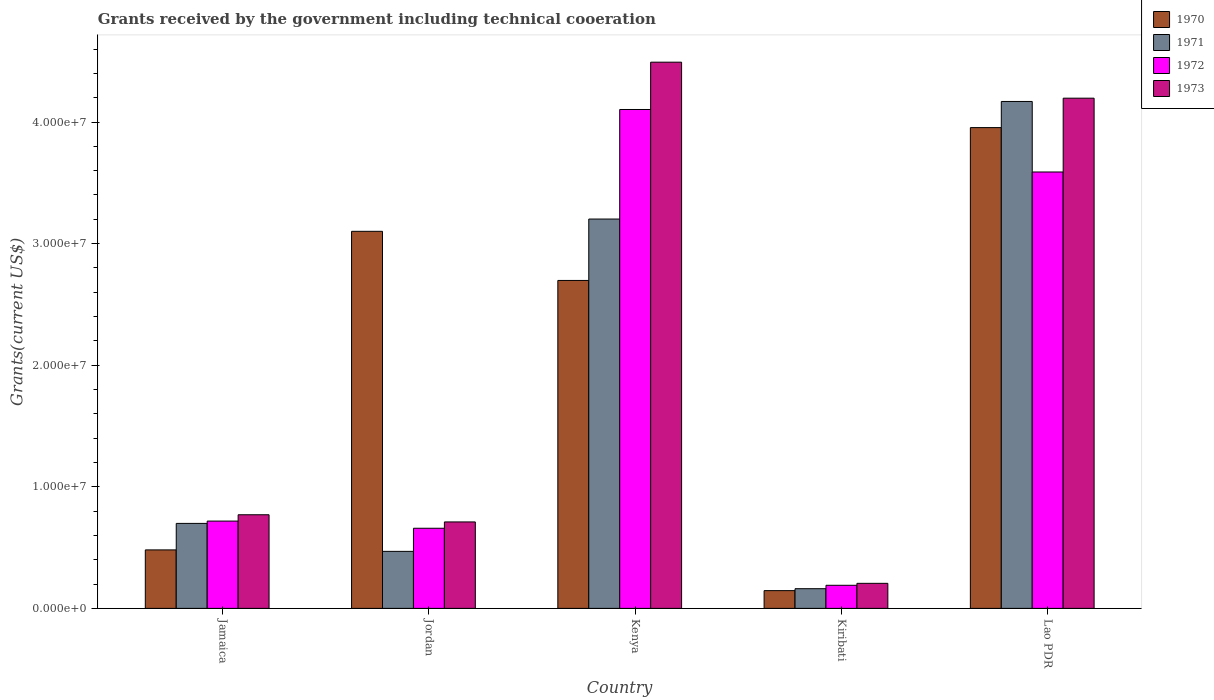How many different coloured bars are there?
Offer a terse response. 4. Are the number of bars per tick equal to the number of legend labels?
Make the answer very short. Yes. Are the number of bars on each tick of the X-axis equal?
Give a very brief answer. Yes. How many bars are there on the 5th tick from the right?
Provide a short and direct response. 4. What is the label of the 3rd group of bars from the left?
Provide a succinct answer. Kenya. What is the total grants received by the government in 1971 in Kiribati?
Your answer should be very brief. 1.62e+06. Across all countries, what is the maximum total grants received by the government in 1971?
Make the answer very short. 4.17e+07. Across all countries, what is the minimum total grants received by the government in 1970?
Provide a succinct answer. 1.46e+06. In which country was the total grants received by the government in 1973 maximum?
Give a very brief answer. Kenya. In which country was the total grants received by the government in 1971 minimum?
Ensure brevity in your answer.  Kiribati. What is the total total grants received by the government in 1970 in the graph?
Your answer should be very brief. 1.04e+08. What is the difference between the total grants received by the government in 1971 in Jamaica and that in Kiribati?
Provide a succinct answer. 5.37e+06. What is the difference between the total grants received by the government in 1971 in Kiribati and the total grants received by the government in 1973 in Kenya?
Make the answer very short. -4.33e+07. What is the average total grants received by the government in 1972 per country?
Make the answer very short. 1.85e+07. What is the difference between the total grants received by the government of/in 1973 and total grants received by the government of/in 1972 in Kenya?
Offer a terse response. 3.89e+06. In how many countries, is the total grants received by the government in 1970 greater than 8000000 US$?
Your answer should be compact. 3. What is the ratio of the total grants received by the government in 1970 in Jamaica to that in Kenya?
Your response must be concise. 0.18. Is the total grants received by the government in 1973 in Kenya less than that in Lao PDR?
Your response must be concise. No. Is the difference between the total grants received by the government in 1973 in Jamaica and Lao PDR greater than the difference between the total grants received by the government in 1972 in Jamaica and Lao PDR?
Offer a very short reply. No. What is the difference between the highest and the second highest total grants received by the government in 1973?
Provide a short and direct response. 3.72e+07. What is the difference between the highest and the lowest total grants received by the government in 1973?
Keep it short and to the point. 4.29e+07. In how many countries, is the total grants received by the government in 1971 greater than the average total grants received by the government in 1971 taken over all countries?
Provide a succinct answer. 2. Is the sum of the total grants received by the government in 1972 in Kenya and Lao PDR greater than the maximum total grants received by the government in 1971 across all countries?
Provide a short and direct response. Yes. Is it the case that in every country, the sum of the total grants received by the government in 1973 and total grants received by the government in 1971 is greater than the sum of total grants received by the government in 1970 and total grants received by the government in 1972?
Keep it short and to the point. No. How many bars are there?
Your response must be concise. 20. What is the difference between two consecutive major ticks on the Y-axis?
Offer a terse response. 1.00e+07. Does the graph contain any zero values?
Provide a short and direct response. No. Does the graph contain grids?
Provide a short and direct response. No. Where does the legend appear in the graph?
Offer a terse response. Top right. What is the title of the graph?
Make the answer very short. Grants received by the government including technical cooeration. What is the label or title of the Y-axis?
Keep it short and to the point. Grants(current US$). What is the Grants(current US$) in 1970 in Jamaica?
Your answer should be very brief. 4.81e+06. What is the Grants(current US$) in 1971 in Jamaica?
Provide a succinct answer. 6.99e+06. What is the Grants(current US$) in 1972 in Jamaica?
Your answer should be very brief. 7.18e+06. What is the Grants(current US$) in 1973 in Jamaica?
Make the answer very short. 7.70e+06. What is the Grants(current US$) in 1970 in Jordan?
Your response must be concise. 3.10e+07. What is the Grants(current US$) in 1971 in Jordan?
Offer a very short reply. 4.69e+06. What is the Grants(current US$) in 1972 in Jordan?
Provide a short and direct response. 6.59e+06. What is the Grants(current US$) of 1973 in Jordan?
Provide a short and direct response. 7.11e+06. What is the Grants(current US$) of 1970 in Kenya?
Your answer should be compact. 2.70e+07. What is the Grants(current US$) in 1971 in Kenya?
Your response must be concise. 3.20e+07. What is the Grants(current US$) in 1972 in Kenya?
Make the answer very short. 4.10e+07. What is the Grants(current US$) in 1973 in Kenya?
Offer a very short reply. 4.49e+07. What is the Grants(current US$) in 1970 in Kiribati?
Ensure brevity in your answer.  1.46e+06. What is the Grants(current US$) of 1971 in Kiribati?
Your response must be concise. 1.62e+06. What is the Grants(current US$) in 1972 in Kiribati?
Your answer should be compact. 1.90e+06. What is the Grants(current US$) of 1973 in Kiribati?
Provide a short and direct response. 2.06e+06. What is the Grants(current US$) of 1970 in Lao PDR?
Your response must be concise. 3.95e+07. What is the Grants(current US$) in 1971 in Lao PDR?
Make the answer very short. 4.17e+07. What is the Grants(current US$) in 1972 in Lao PDR?
Your answer should be very brief. 3.59e+07. What is the Grants(current US$) of 1973 in Lao PDR?
Your response must be concise. 4.20e+07. Across all countries, what is the maximum Grants(current US$) of 1970?
Your answer should be compact. 3.95e+07. Across all countries, what is the maximum Grants(current US$) of 1971?
Offer a very short reply. 4.17e+07. Across all countries, what is the maximum Grants(current US$) in 1972?
Provide a short and direct response. 4.10e+07. Across all countries, what is the maximum Grants(current US$) in 1973?
Provide a short and direct response. 4.49e+07. Across all countries, what is the minimum Grants(current US$) of 1970?
Ensure brevity in your answer.  1.46e+06. Across all countries, what is the minimum Grants(current US$) in 1971?
Ensure brevity in your answer.  1.62e+06. Across all countries, what is the minimum Grants(current US$) of 1972?
Your answer should be very brief. 1.90e+06. Across all countries, what is the minimum Grants(current US$) in 1973?
Make the answer very short. 2.06e+06. What is the total Grants(current US$) of 1970 in the graph?
Your response must be concise. 1.04e+08. What is the total Grants(current US$) in 1971 in the graph?
Give a very brief answer. 8.70e+07. What is the total Grants(current US$) in 1972 in the graph?
Your answer should be very brief. 9.26e+07. What is the total Grants(current US$) in 1973 in the graph?
Make the answer very short. 1.04e+08. What is the difference between the Grants(current US$) in 1970 in Jamaica and that in Jordan?
Provide a succinct answer. -2.62e+07. What is the difference between the Grants(current US$) in 1971 in Jamaica and that in Jordan?
Your response must be concise. 2.30e+06. What is the difference between the Grants(current US$) in 1972 in Jamaica and that in Jordan?
Offer a terse response. 5.90e+05. What is the difference between the Grants(current US$) in 1973 in Jamaica and that in Jordan?
Keep it short and to the point. 5.90e+05. What is the difference between the Grants(current US$) in 1970 in Jamaica and that in Kenya?
Ensure brevity in your answer.  -2.22e+07. What is the difference between the Grants(current US$) of 1971 in Jamaica and that in Kenya?
Make the answer very short. -2.50e+07. What is the difference between the Grants(current US$) of 1972 in Jamaica and that in Kenya?
Offer a terse response. -3.38e+07. What is the difference between the Grants(current US$) of 1973 in Jamaica and that in Kenya?
Your answer should be compact. -3.72e+07. What is the difference between the Grants(current US$) in 1970 in Jamaica and that in Kiribati?
Offer a terse response. 3.35e+06. What is the difference between the Grants(current US$) in 1971 in Jamaica and that in Kiribati?
Your response must be concise. 5.37e+06. What is the difference between the Grants(current US$) in 1972 in Jamaica and that in Kiribati?
Offer a terse response. 5.28e+06. What is the difference between the Grants(current US$) of 1973 in Jamaica and that in Kiribati?
Keep it short and to the point. 5.64e+06. What is the difference between the Grants(current US$) of 1970 in Jamaica and that in Lao PDR?
Make the answer very short. -3.47e+07. What is the difference between the Grants(current US$) in 1971 in Jamaica and that in Lao PDR?
Your answer should be compact. -3.47e+07. What is the difference between the Grants(current US$) of 1972 in Jamaica and that in Lao PDR?
Your response must be concise. -2.87e+07. What is the difference between the Grants(current US$) of 1973 in Jamaica and that in Lao PDR?
Offer a terse response. -3.43e+07. What is the difference between the Grants(current US$) of 1970 in Jordan and that in Kenya?
Give a very brief answer. 4.04e+06. What is the difference between the Grants(current US$) in 1971 in Jordan and that in Kenya?
Offer a terse response. -2.73e+07. What is the difference between the Grants(current US$) in 1972 in Jordan and that in Kenya?
Offer a very short reply. -3.44e+07. What is the difference between the Grants(current US$) of 1973 in Jordan and that in Kenya?
Your response must be concise. -3.78e+07. What is the difference between the Grants(current US$) of 1970 in Jordan and that in Kiribati?
Provide a short and direct response. 2.96e+07. What is the difference between the Grants(current US$) of 1971 in Jordan and that in Kiribati?
Ensure brevity in your answer.  3.07e+06. What is the difference between the Grants(current US$) of 1972 in Jordan and that in Kiribati?
Keep it short and to the point. 4.69e+06. What is the difference between the Grants(current US$) of 1973 in Jordan and that in Kiribati?
Keep it short and to the point. 5.05e+06. What is the difference between the Grants(current US$) in 1970 in Jordan and that in Lao PDR?
Your answer should be compact. -8.53e+06. What is the difference between the Grants(current US$) of 1971 in Jordan and that in Lao PDR?
Keep it short and to the point. -3.70e+07. What is the difference between the Grants(current US$) of 1972 in Jordan and that in Lao PDR?
Give a very brief answer. -2.93e+07. What is the difference between the Grants(current US$) in 1973 in Jordan and that in Lao PDR?
Make the answer very short. -3.48e+07. What is the difference between the Grants(current US$) in 1970 in Kenya and that in Kiribati?
Provide a succinct answer. 2.55e+07. What is the difference between the Grants(current US$) of 1971 in Kenya and that in Kiribati?
Ensure brevity in your answer.  3.04e+07. What is the difference between the Grants(current US$) in 1972 in Kenya and that in Kiribati?
Your answer should be very brief. 3.91e+07. What is the difference between the Grants(current US$) in 1973 in Kenya and that in Kiribati?
Offer a terse response. 4.29e+07. What is the difference between the Grants(current US$) of 1970 in Kenya and that in Lao PDR?
Give a very brief answer. -1.26e+07. What is the difference between the Grants(current US$) in 1971 in Kenya and that in Lao PDR?
Offer a terse response. -9.67e+06. What is the difference between the Grants(current US$) in 1972 in Kenya and that in Lao PDR?
Ensure brevity in your answer.  5.14e+06. What is the difference between the Grants(current US$) of 1973 in Kenya and that in Lao PDR?
Ensure brevity in your answer.  2.96e+06. What is the difference between the Grants(current US$) in 1970 in Kiribati and that in Lao PDR?
Your response must be concise. -3.81e+07. What is the difference between the Grants(current US$) of 1971 in Kiribati and that in Lao PDR?
Keep it short and to the point. -4.01e+07. What is the difference between the Grants(current US$) in 1972 in Kiribati and that in Lao PDR?
Provide a succinct answer. -3.40e+07. What is the difference between the Grants(current US$) of 1973 in Kiribati and that in Lao PDR?
Provide a short and direct response. -3.99e+07. What is the difference between the Grants(current US$) in 1970 in Jamaica and the Grants(current US$) in 1972 in Jordan?
Provide a succinct answer. -1.78e+06. What is the difference between the Grants(current US$) in 1970 in Jamaica and the Grants(current US$) in 1973 in Jordan?
Provide a short and direct response. -2.30e+06. What is the difference between the Grants(current US$) of 1971 in Jamaica and the Grants(current US$) of 1972 in Jordan?
Your response must be concise. 4.00e+05. What is the difference between the Grants(current US$) in 1970 in Jamaica and the Grants(current US$) in 1971 in Kenya?
Keep it short and to the point. -2.72e+07. What is the difference between the Grants(current US$) in 1970 in Jamaica and the Grants(current US$) in 1972 in Kenya?
Provide a succinct answer. -3.62e+07. What is the difference between the Grants(current US$) of 1970 in Jamaica and the Grants(current US$) of 1973 in Kenya?
Provide a succinct answer. -4.01e+07. What is the difference between the Grants(current US$) of 1971 in Jamaica and the Grants(current US$) of 1972 in Kenya?
Keep it short and to the point. -3.40e+07. What is the difference between the Grants(current US$) of 1971 in Jamaica and the Grants(current US$) of 1973 in Kenya?
Offer a terse response. -3.79e+07. What is the difference between the Grants(current US$) of 1972 in Jamaica and the Grants(current US$) of 1973 in Kenya?
Offer a very short reply. -3.77e+07. What is the difference between the Grants(current US$) in 1970 in Jamaica and the Grants(current US$) in 1971 in Kiribati?
Your answer should be compact. 3.19e+06. What is the difference between the Grants(current US$) of 1970 in Jamaica and the Grants(current US$) of 1972 in Kiribati?
Keep it short and to the point. 2.91e+06. What is the difference between the Grants(current US$) in 1970 in Jamaica and the Grants(current US$) in 1973 in Kiribati?
Make the answer very short. 2.75e+06. What is the difference between the Grants(current US$) in 1971 in Jamaica and the Grants(current US$) in 1972 in Kiribati?
Make the answer very short. 5.09e+06. What is the difference between the Grants(current US$) in 1971 in Jamaica and the Grants(current US$) in 1973 in Kiribati?
Ensure brevity in your answer.  4.93e+06. What is the difference between the Grants(current US$) of 1972 in Jamaica and the Grants(current US$) of 1973 in Kiribati?
Provide a succinct answer. 5.12e+06. What is the difference between the Grants(current US$) in 1970 in Jamaica and the Grants(current US$) in 1971 in Lao PDR?
Your answer should be compact. -3.69e+07. What is the difference between the Grants(current US$) of 1970 in Jamaica and the Grants(current US$) of 1972 in Lao PDR?
Provide a short and direct response. -3.11e+07. What is the difference between the Grants(current US$) in 1970 in Jamaica and the Grants(current US$) in 1973 in Lao PDR?
Your answer should be very brief. -3.72e+07. What is the difference between the Grants(current US$) in 1971 in Jamaica and the Grants(current US$) in 1972 in Lao PDR?
Provide a short and direct response. -2.89e+07. What is the difference between the Grants(current US$) of 1971 in Jamaica and the Grants(current US$) of 1973 in Lao PDR?
Your response must be concise. -3.50e+07. What is the difference between the Grants(current US$) of 1972 in Jamaica and the Grants(current US$) of 1973 in Lao PDR?
Offer a terse response. -3.48e+07. What is the difference between the Grants(current US$) of 1970 in Jordan and the Grants(current US$) of 1971 in Kenya?
Your answer should be compact. -1.01e+06. What is the difference between the Grants(current US$) in 1970 in Jordan and the Grants(current US$) in 1972 in Kenya?
Provide a succinct answer. -1.00e+07. What is the difference between the Grants(current US$) of 1970 in Jordan and the Grants(current US$) of 1973 in Kenya?
Offer a very short reply. -1.39e+07. What is the difference between the Grants(current US$) in 1971 in Jordan and the Grants(current US$) in 1972 in Kenya?
Provide a succinct answer. -3.63e+07. What is the difference between the Grants(current US$) in 1971 in Jordan and the Grants(current US$) in 1973 in Kenya?
Your response must be concise. -4.02e+07. What is the difference between the Grants(current US$) in 1972 in Jordan and the Grants(current US$) in 1973 in Kenya?
Your answer should be very brief. -3.83e+07. What is the difference between the Grants(current US$) of 1970 in Jordan and the Grants(current US$) of 1971 in Kiribati?
Your answer should be very brief. 2.94e+07. What is the difference between the Grants(current US$) in 1970 in Jordan and the Grants(current US$) in 1972 in Kiribati?
Ensure brevity in your answer.  2.91e+07. What is the difference between the Grants(current US$) in 1970 in Jordan and the Grants(current US$) in 1973 in Kiribati?
Make the answer very short. 2.90e+07. What is the difference between the Grants(current US$) in 1971 in Jordan and the Grants(current US$) in 1972 in Kiribati?
Your response must be concise. 2.79e+06. What is the difference between the Grants(current US$) of 1971 in Jordan and the Grants(current US$) of 1973 in Kiribati?
Provide a succinct answer. 2.63e+06. What is the difference between the Grants(current US$) in 1972 in Jordan and the Grants(current US$) in 1973 in Kiribati?
Give a very brief answer. 4.53e+06. What is the difference between the Grants(current US$) of 1970 in Jordan and the Grants(current US$) of 1971 in Lao PDR?
Keep it short and to the point. -1.07e+07. What is the difference between the Grants(current US$) in 1970 in Jordan and the Grants(current US$) in 1972 in Lao PDR?
Your answer should be compact. -4.88e+06. What is the difference between the Grants(current US$) in 1970 in Jordan and the Grants(current US$) in 1973 in Lao PDR?
Keep it short and to the point. -1.10e+07. What is the difference between the Grants(current US$) in 1971 in Jordan and the Grants(current US$) in 1972 in Lao PDR?
Offer a terse response. -3.12e+07. What is the difference between the Grants(current US$) in 1971 in Jordan and the Grants(current US$) in 1973 in Lao PDR?
Make the answer very short. -3.73e+07. What is the difference between the Grants(current US$) of 1972 in Jordan and the Grants(current US$) of 1973 in Lao PDR?
Keep it short and to the point. -3.54e+07. What is the difference between the Grants(current US$) of 1970 in Kenya and the Grants(current US$) of 1971 in Kiribati?
Keep it short and to the point. 2.54e+07. What is the difference between the Grants(current US$) in 1970 in Kenya and the Grants(current US$) in 1972 in Kiribati?
Ensure brevity in your answer.  2.51e+07. What is the difference between the Grants(current US$) in 1970 in Kenya and the Grants(current US$) in 1973 in Kiribati?
Offer a very short reply. 2.49e+07. What is the difference between the Grants(current US$) of 1971 in Kenya and the Grants(current US$) of 1972 in Kiribati?
Ensure brevity in your answer.  3.01e+07. What is the difference between the Grants(current US$) in 1971 in Kenya and the Grants(current US$) in 1973 in Kiribati?
Keep it short and to the point. 3.00e+07. What is the difference between the Grants(current US$) in 1972 in Kenya and the Grants(current US$) in 1973 in Kiribati?
Offer a terse response. 3.90e+07. What is the difference between the Grants(current US$) in 1970 in Kenya and the Grants(current US$) in 1971 in Lao PDR?
Offer a very short reply. -1.47e+07. What is the difference between the Grants(current US$) in 1970 in Kenya and the Grants(current US$) in 1972 in Lao PDR?
Provide a short and direct response. -8.92e+06. What is the difference between the Grants(current US$) in 1970 in Kenya and the Grants(current US$) in 1973 in Lao PDR?
Make the answer very short. -1.50e+07. What is the difference between the Grants(current US$) of 1971 in Kenya and the Grants(current US$) of 1972 in Lao PDR?
Offer a terse response. -3.87e+06. What is the difference between the Grants(current US$) in 1971 in Kenya and the Grants(current US$) in 1973 in Lao PDR?
Offer a terse response. -9.94e+06. What is the difference between the Grants(current US$) in 1972 in Kenya and the Grants(current US$) in 1973 in Lao PDR?
Give a very brief answer. -9.30e+05. What is the difference between the Grants(current US$) in 1970 in Kiribati and the Grants(current US$) in 1971 in Lao PDR?
Offer a terse response. -4.02e+07. What is the difference between the Grants(current US$) of 1970 in Kiribati and the Grants(current US$) of 1972 in Lao PDR?
Your answer should be compact. -3.44e+07. What is the difference between the Grants(current US$) of 1970 in Kiribati and the Grants(current US$) of 1973 in Lao PDR?
Give a very brief answer. -4.05e+07. What is the difference between the Grants(current US$) of 1971 in Kiribati and the Grants(current US$) of 1972 in Lao PDR?
Make the answer very short. -3.43e+07. What is the difference between the Grants(current US$) of 1971 in Kiribati and the Grants(current US$) of 1973 in Lao PDR?
Make the answer very short. -4.03e+07. What is the difference between the Grants(current US$) in 1972 in Kiribati and the Grants(current US$) in 1973 in Lao PDR?
Provide a succinct answer. -4.01e+07. What is the average Grants(current US$) in 1970 per country?
Give a very brief answer. 2.08e+07. What is the average Grants(current US$) in 1971 per country?
Offer a very short reply. 1.74e+07. What is the average Grants(current US$) of 1972 per country?
Your response must be concise. 1.85e+07. What is the average Grants(current US$) of 1973 per country?
Make the answer very short. 2.08e+07. What is the difference between the Grants(current US$) of 1970 and Grants(current US$) of 1971 in Jamaica?
Provide a succinct answer. -2.18e+06. What is the difference between the Grants(current US$) of 1970 and Grants(current US$) of 1972 in Jamaica?
Your answer should be very brief. -2.37e+06. What is the difference between the Grants(current US$) in 1970 and Grants(current US$) in 1973 in Jamaica?
Ensure brevity in your answer.  -2.89e+06. What is the difference between the Grants(current US$) of 1971 and Grants(current US$) of 1973 in Jamaica?
Offer a very short reply. -7.10e+05. What is the difference between the Grants(current US$) in 1972 and Grants(current US$) in 1973 in Jamaica?
Provide a succinct answer. -5.20e+05. What is the difference between the Grants(current US$) of 1970 and Grants(current US$) of 1971 in Jordan?
Give a very brief answer. 2.63e+07. What is the difference between the Grants(current US$) of 1970 and Grants(current US$) of 1972 in Jordan?
Offer a terse response. 2.44e+07. What is the difference between the Grants(current US$) in 1970 and Grants(current US$) in 1973 in Jordan?
Your answer should be very brief. 2.39e+07. What is the difference between the Grants(current US$) of 1971 and Grants(current US$) of 1972 in Jordan?
Your answer should be very brief. -1.90e+06. What is the difference between the Grants(current US$) of 1971 and Grants(current US$) of 1973 in Jordan?
Offer a terse response. -2.42e+06. What is the difference between the Grants(current US$) of 1972 and Grants(current US$) of 1973 in Jordan?
Provide a succinct answer. -5.20e+05. What is the difference between the Grants(current US$) in 1970 and Grants(current US$) in 1971 in Kenya?
Offer a terse response. -5.05e+06. What is the difference between the Grants(current US$) in 1970 and Grants(current US$) in 1972 in Kenya?
Your answer should be compact. -1.41e+07. What is the difference between the Grants(current US$) in 1970 and Grants(current US$) in 1973 in Kenya?
Your answer should be compact. -1.80e+07. What is the difference between the Grants(current US$) of 1971 and Grants(current US$) of 1972 in Kenya?
Make the answer very short. -9.01e+06. What is the difference between the Grants(current US$) of 1971 and Grants(current US$) of 1973 in Kenya?
Provide a succinct answer. -1.29e+07. What is the difference between the Grants(current US$) of 1972 and Grants(current US$) of 1973 in Kenya?
Keep it short and to the point. -3.89e+06. What is the difference between the Grants(current US$) of 1970 and Grants(current US$) of 1971 in Kiribati?
Your answer should be very brief. -1.60e+05. What is the difference between the Grants(current US$) of 1970 and Grants(current US$) of 1972 in Kiribati?
Provide a succinct answer. -4.40e+05. What is the difference between the Grants(current US$) in 1970 and Grants(current US$) in 1973 in Kiribati?
Ensure brevity in your answer.  -6.00e+05. What is the difference between the Grants(current US$) in 1971 and Grants(current US$) in 1972 in Kiribati?
Your answer should be very brief. -2.80e+05. What is the difference between the Grants(current US$) of 1971 and Grants(current US$) of 1973 in Kiribati?
Provide a short and direct response. -4.40e+05. What is the difference between the Grants(current US$) in 1970 and Grants(current US$) in 1971 in Lao PDR?
Your answer should be very brief. -2.15e+06. What is the difference between the Grants(current US$) in 1970 and Grants(current US$) in 1972 in Lao PDR?
Provide a succinct answer. 3.65e+06. What is the difference between the Grants(current US$) of 1970 and Grants(current US$) of 1973 in Lao PDR?
Give a very brief answer. -2.42e+06. What is the difference between the Grants(current US$) of 1971 and Grants(current US$) of 1972 in Lao PDR?
Make the answer very short. 5.80e+06. What is the difference between the Grants(current US$) of 1971 and Grants(current US$) of 1973 in Lao PDR?
Offer a very short reply. -2.70e+05. What is the difference between the Grants(current US$) in 1972 and Grants(current US$) in 1973 in Lao PDR?
Make the answer very short. -6.07e+06. What is the ratio of the Grants(current US$) in 1970 in Jamaica to that in Jordan?
Make the answer very short. 0.16. What is the ratio of the Grants(current US$) in 1971 in Jamaica to that in Jordan?
Offer a terse response. 1.49. What is the ratio of the Grants(current US$) of 1972 in Jamaica to that in Jordan?
Provide a short and direct response. 1.09. What is the ratio of the Grants(current US$) of 1973 in Jamaica to that in Jordan?
Provide a succinct answer. 1.08. What is the ratio of the Grants(current US$) of 1970 in Jamaica to that in Kenya?
Keep it short and to the point. 0.18. What is the ratio of the Grants(current US$) of 1971 in Jamaica to that in Kenya?
Provide a short and direct response. 0.22. What is the ratio of the Grants(current US$) of 1972 in Jamaica to that in Kenya?
Make the answer very short. 0.17. What is the ratio of the Grants(current US$) in 1973 in Jamaica to that in Kenya?
Offer a terse response. 0.17. What is the ratio of the Grants(current US$) of 1970 in Jamaica to that in Kiribati?
Give a very brief answer. 3.29. What is the ratio of the Grants(current US$) in 1971 in Jamaica to that in Kiribati?
Your response must be concise. 4.31. What is the ratio of the Grants(current US$) of 1972 in Jamaica to that in Kiribati?
Your answer should be very brief. 3.78. What is the ratio of the Grants(current US$) of 1973 in Jamaica to that in Kiribati?
Your answer should be compact. 3.74. What is the ratio of the Grants(current US$) of 1970 in Jamaica to that in Lao PDR?
Make the answer very short. 0.12. What is the ratio of the Grants(current US$) in 1971 in Jamaica to that in Lao PDR?
Offer a very short reply. 0.17. What is the ratio of the Grants(current US$) in 1972 in Jamaica to that in Lao PDR?
Keep it short and to the point. 0.2. What is the ratio of the Grants(current US$) of 1973 in Jamaica to that in Lao PDR?
Provide a short and direct response. 0.18. What is the ratio of the Grants(current US$) in 1970 in Jordan to that in Kenya?
Keep it short and to the point. 1.15. What is the ratio of the Grants(current US$) in 1971 in Jordan to that in Kenya?
Offer a very short reply. 0.15. What is the ratio of the Grants(current US$) in 1972 in Jordan to that in Kenya?
Offer a very short reply. 0.16. What is the ratio of the Grants(current US$) of 1973 in Jordan to that in Kenya?
Provide a succinct answer. 0.16. What is the ratio of the Grants(current US$) in 1970 in Jordan to that in Kiribati?
Give a very brief answer. 21.24. What is the ratio of the Grants(current US$) in 1971 in Jordan to that in Kiribati?
Offer a terse response. 2.9. What is the ratio of the Grants(current US$) of 1972 in Jordan to that in Kiribati?
Ensure brevity in your answer.  3.47. What is the ratio of the Grants(current US$) of 1973 in Jordan to that in Kiribati?
Your response must be concise. 3.45. What is the ratio of the Grants(current US$) of 1970 in Jordan to that in Lao PDR?
Your answer should be compact. 0.78. What is the ratio of the Grants(current US$) of 1971 in Jordan to that in Lao PDR?
Your answer should be very brief. 0.11. What is the ratio of the Grants(current US$) in 1972 in Jordan to that in Lao PDR?
Your answer should be very brief. 0.18. What is the ratio of the Grants(current US$) of 1973 in Jordan to that in Lao PDR?
Provide a succinct answer. 0.17. What is the ratio of the Grants(current US$) in 1970 in Kenya to that in Kiribati?
Provide a succinct answer. 18.47. What is the ratio of the Grants(current US$) of 1971 in Kenya to that in Kiribati?
Keep it short and to the point. 19.77. What is the ratio of the Grants(current US$) of 1972 in Kenya to that in Kiribati?
Offer a very short reply. 21.59. What is the ratio of the Grants(current US$) in 1973 in Kenya to that in Kiribati?
Your answer should be compact. 21.81. What is the ratio of the Grants(current US$) of 1970 in Kenya to that in Lao PDR?
Provide a short and direct response. 0.68. What is the ratio of the Grants(current US$) in 1971 in Kenya to that in Lao PDR?
Ensure brevity in your answer.  0.77. What is the ratio of the Grants(current US$) of 1972 in Kenya to that in Lao PDR?
Ensure brevity in your answer.  1.14. What is the ratio of the Grants(current US$) of 1973 in Kenya to that in Lao PDR?
Give a very brief answer. 1.07. What is the ratio of the Grants(current US$) of 1970 in Kiribati to that in Lao PDR?
Make the answer very short. 0.04. What is the ratio of the Grants(current US$) in 1971 in Kiribati to that in Lao PDR?
Ensure brevity in your answer.  0.04. What is the ratio of the Grants(current US$) in 1972 in Kiribati to that in Lao PDR?
Offer a very short reply. 0.05. What is the ratio of the Grants(current US$) of 1973 in Kiribati to that in Lao PDR?
Your answer should be compact. 0.05. What is the difference between the highest and the second highest Grants(current US$) in 1970?
Make the answer very short. 8.53e+06. What is the difference between the highest and the second highest Grants(current US$) in 1971?
Provide a succinct answer. 9.67e+06. What is the difference between the highest and the second highest Grants(current US$) of 1972?
Offer a terse response. 5.14e+06. What is the difference between the highest and the second highest Grants(current US$) of 1973?
Your response must be concise. 2.96e+06. What is the difference between the highest and the lowest Grants(current US$) of 1970?
Your answer should be very brief. 3.81e+07. What is the difference between the highest and the lowest Grants(current US$) in 1971?
Make the answer very short. 4.01e+07. What is the difference between the highest and the lowest Grants(current US$) of 1972?
Your answer should be compact. 3.91e+07. What is the difference between the highest and the lowest Grants(current US$) in 1973?
Provide a succinct answer. 4.29e+07. 